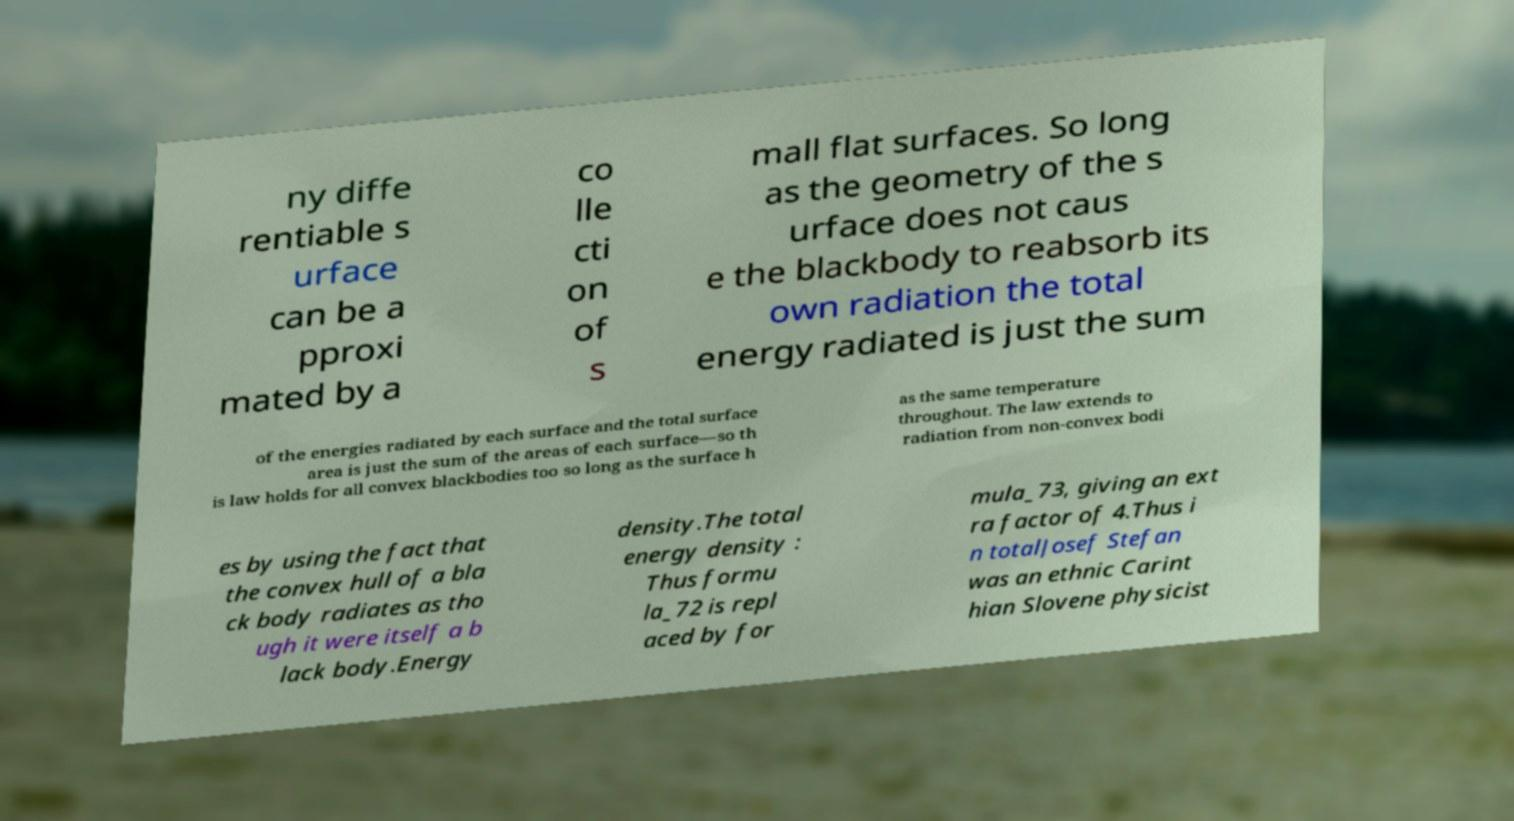Could you extract and type out the text from this image? ny diffe rentiable s urface can be a pproxi mated by a co lle cti on of s mall flat surfaces. So long as the geometry of the s urface does not caus e the blackbody to reabsorb its own radiation the total energy radiated is just the sum of the energies radiated by each surface and the total surface area is just the sum of the areas of each surface—so th is law holds for all convex blackbodies too so long as the surface h as the same temperature throughout. The law extends to radiation from non-convex bodi es by using the fact that the convex hull of a bla ck body radiates as tho ugh it were itself a b lack body.Energy density.The total energy density : Thus formu la_72 is repl aced by for mula_73, giving an ext ra factor of 4.Thus i n totalJosef Stefan was an ethnic Carint hian Slovene physicist 